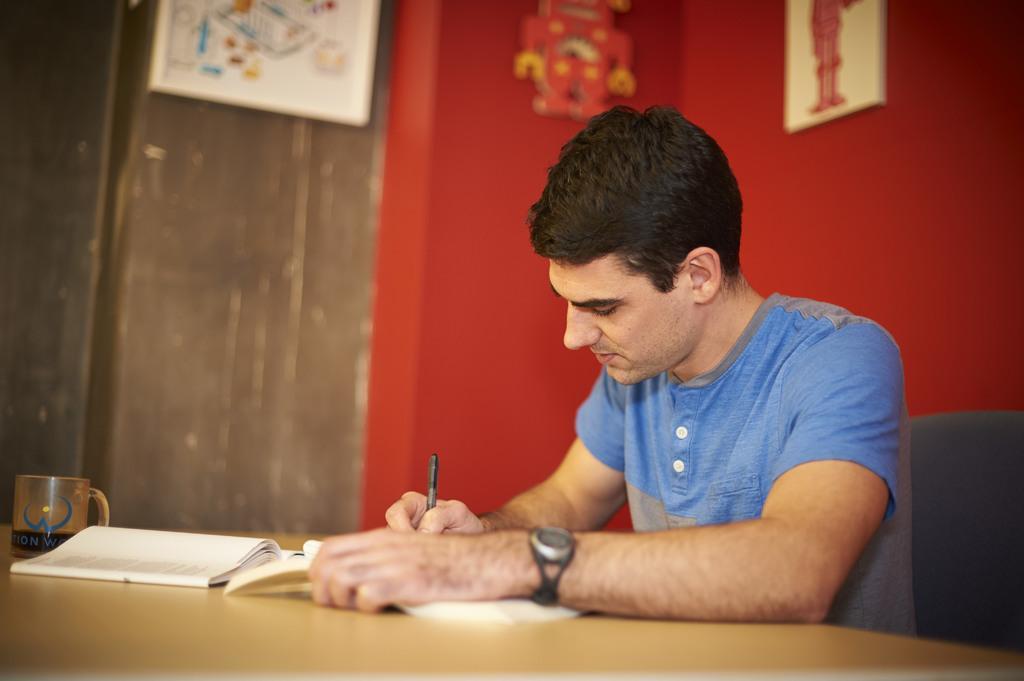Describe this image in one or two sentences. In this picture we can see man wore blue color T-Shirt sitting on chair and writing with pen on paper placed on table and we have cup on the same table and in background we can see wall with frames. 